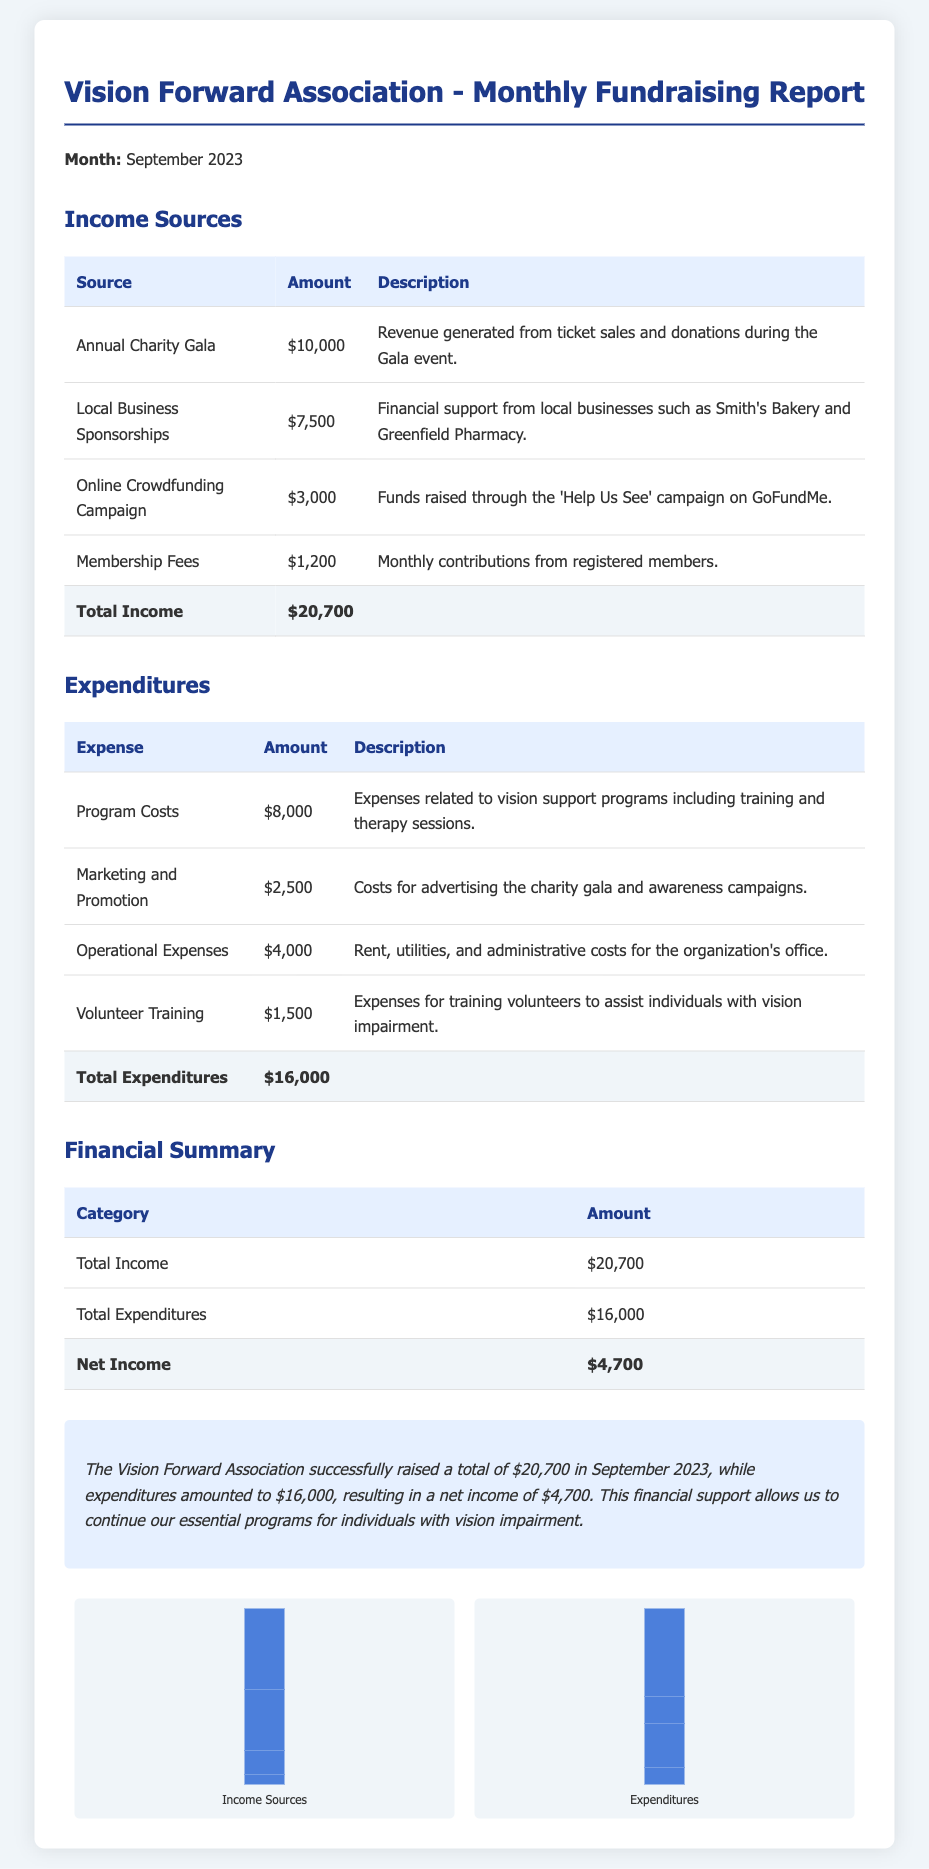What is the total income for September 2023? The total income is listed at the bottom of the Income Sources table, which adds all income sources together.
Answer: $20,700 What are local business sponsorships? Local business sponsorships are mentioned as a specific source of income, detailed under Income Sources.
Answer: $7,500 What was spent on program costs? Program costs are specified in the Expenditures section, where the amount is indicated.
Answer: $8,000 What is the net income for the organization? The net income is calculated by subtracting total expenditures from total income, found in the Financial Summary section.
Answer: $4,700 Which event generated revenue through ticket sales and donations? The specific event that generated revenue is highlighted in the Income Sources table as part of its description.
Answer: Annual Charity Gala What were the total expenditures for September 2023? The total expenditures are provided at the end of the Expenditures section, summing all listed expenses.
Answer: $16,000 How much money was raised through the online crowdfunding campaign? The amount raised from the crowdfunding campaign is directly stated in the Income Sources section.
Answer: $3,000 What is the description of the expenditure for volunteer training? The description includes detailed information about the purpose of the spending, found in the Expenditures section.
Answer: Expenses for training volunteers to assist individuals with vision impairment What are operational expenses? Operational expenses are categorized in the Expenditures section, where they are clearly defined and quantified.
Answer: $4,000 